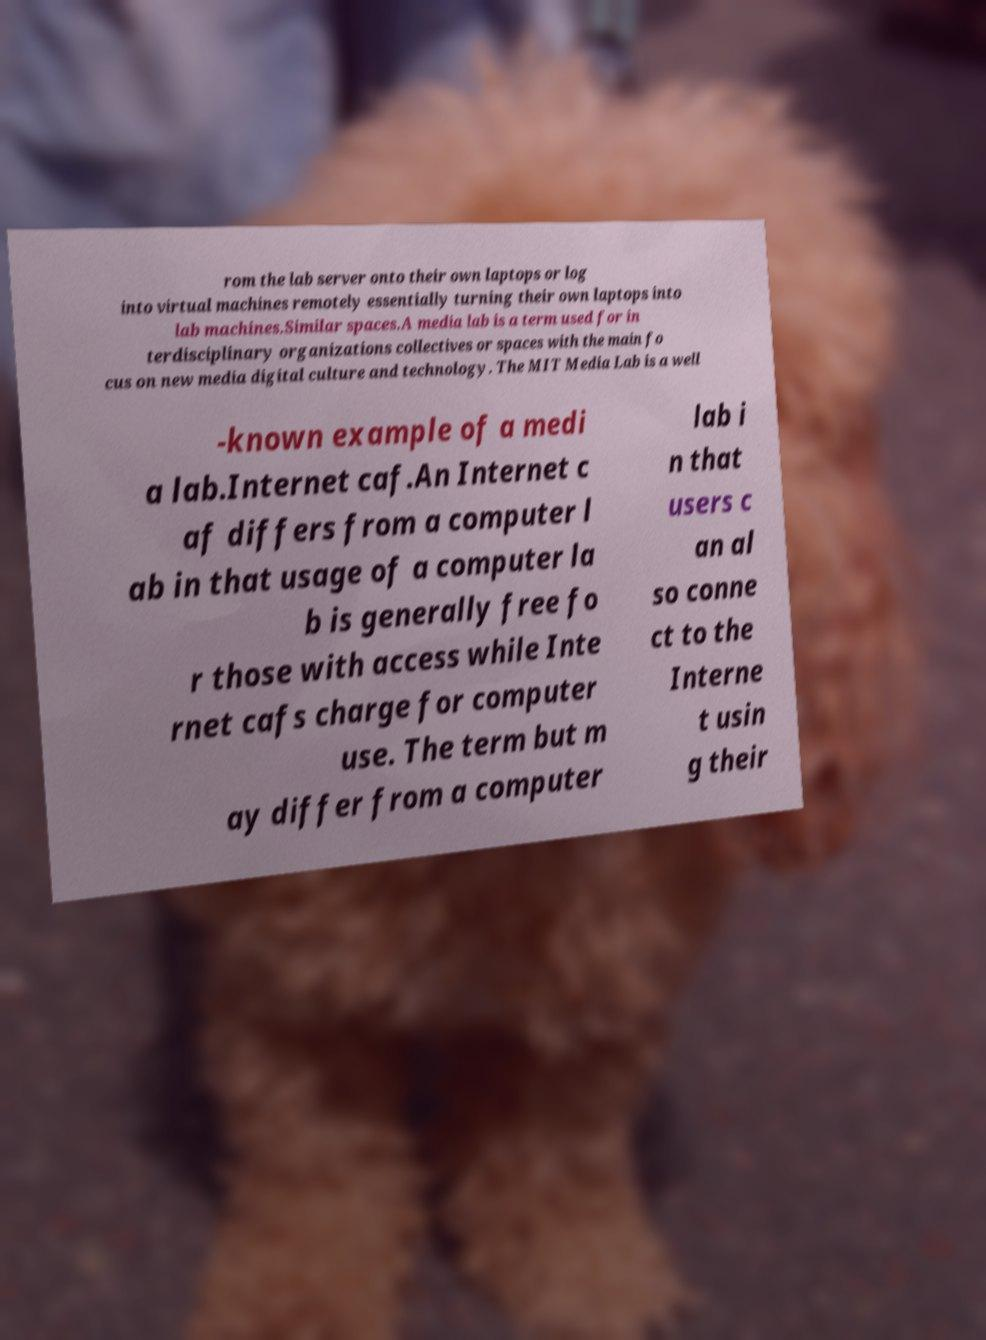Can you accurately transcribe the text from the provided image for me? rom the lab server onto their own laptops or log into virtual machines remotely essentially turning their own laptops into lab machines.Similar spaces.A media lab is a term used for in terdisciplinary organizations collectives or spaces with the main fo cus on new media digital culture and technology. The MIT Media Lab is a well -known example of a medi a lab.Internet caf.An Internet c af differs from a computer l ab in that usage of a computer la b is generally free fo r those with access while Inte rnet cafs charge for computer use. The term but m ay differ from a computer lab i n that users c an al so conne ct to the Interne t usin g their 